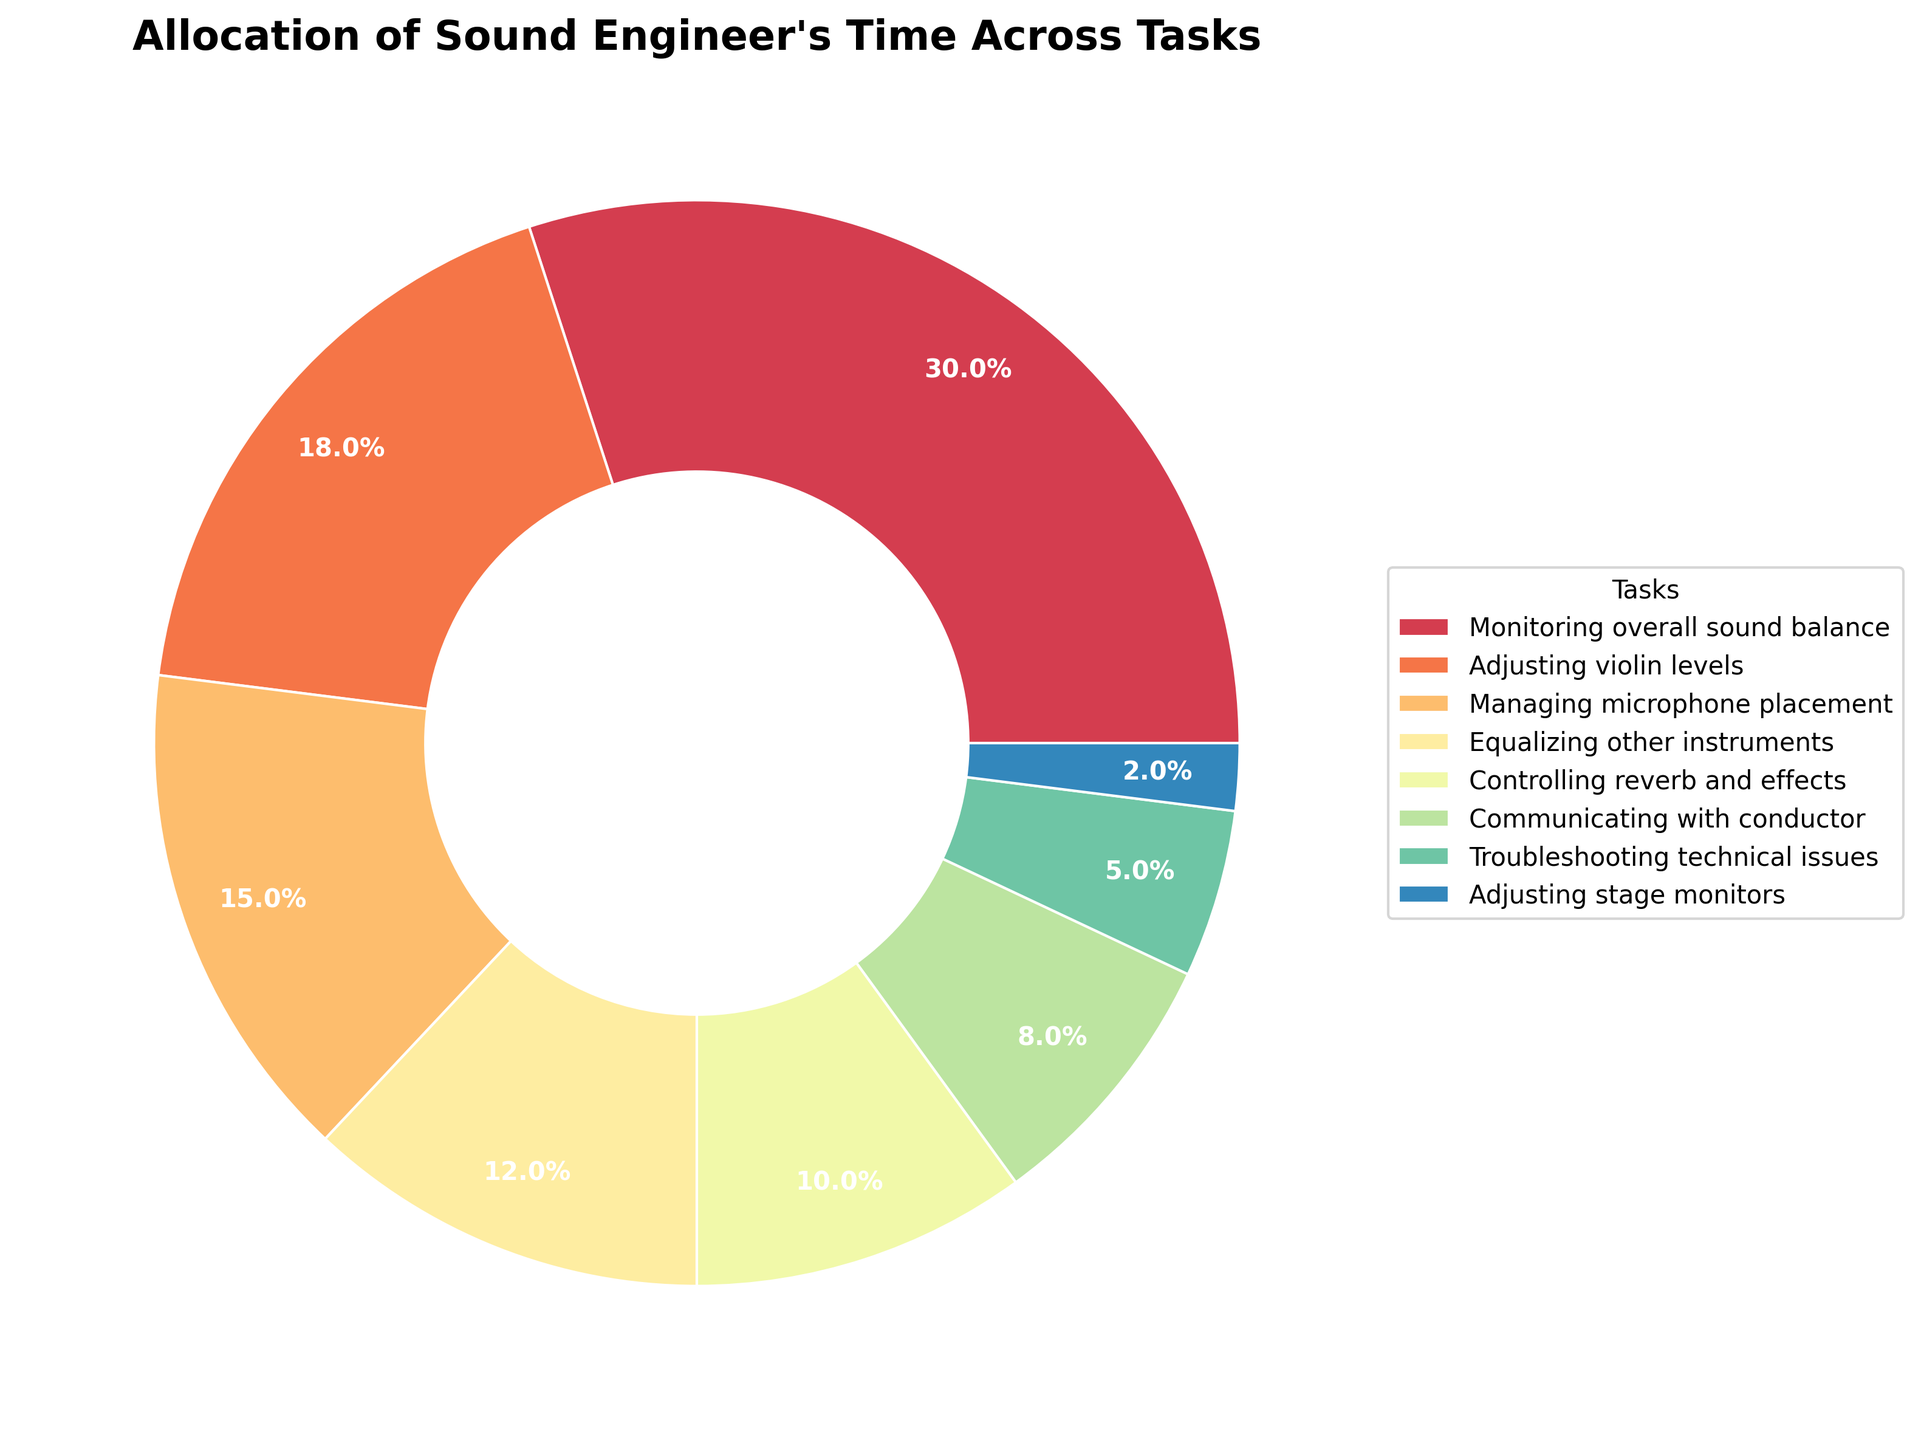What's the largest allocation of time in the chart? Identify the segment with the largest value. The pie chart shows "Monitoring overall sound balance" at 30%, which is the biggest slice.
Answer: Monitoring overall sound balance What's the combined percentage of time spent on "Communicating with conductor" and "Troubleshooting technical issues"? Find the percentages of "Communicating with conductor" (8%) and "Troubleshooting technical issues" (5%), and then add them together: 8% + 5% = 13%.
Answer: 13% Which task takes up less time: "Managing microphone placement" or "Adjusting violin levels"? Compare the slices for "Managing microphone placement" (15%) and "Adjusting violin levels" (18%). Managing microphone placement is less.
Answer: Managing microphone placement What's the total percentage of time spent on tasks related to modifying audio levels for individual instruments? Sum the percentages of tasks associated with modifying audio levels: "Adjusting violin levels" (18%) and "Equalizing other instruments" (12%): 18% + 12% = 30%.
Answer: 30% Which task has a larger percentage, "Controlling reverb and effects" or "Adjusting stage monitors"? Compare the slices for "Controlling reverb and effects" (10%) and "Adjusting stage monitors" (2%). Controlling reverb and effects is larger.
Answer: Controlling reverb and effects What's the difference in percentage between the time spent on "Equalizing other instruments" and "Communicating with conductor"? Subtract the percentage of "Communicating with conductor" (8%) from "Equalizing other instruments" (12%): 12% - 8% = 4%.
Answer: 4% Which tasks each make up more than 15% of the total time? Identify the tasks with percentages greater than 15%. These are "Monitoring overall sound balance" (30%) and "Adjusting violin levels" (18%).
Answer: Monitoring overall sound balance and Adjusting violin levels What percentage of time is devoted to tasks not directly involving the orchestra's sound during the performance? Sum the percentages for "Communicating with conductor" (8%) and "Troubleshooting technical issues" (5%): 8% + 5% = 13%.
Answer: 13% 